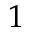Convert formula to latex. <formula><loc_0><loc_0><loc_500><loc_500>1</formula> 